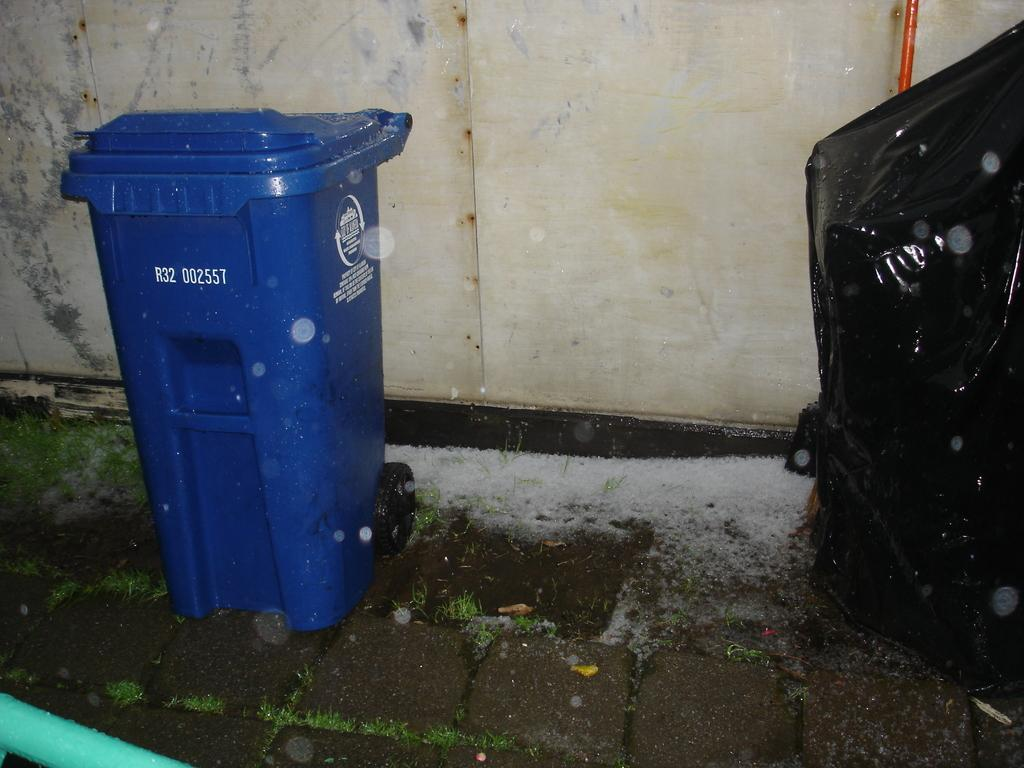<image>
Present a compact description of the photo's key features. Blue garbage can which says R32 on the front. 